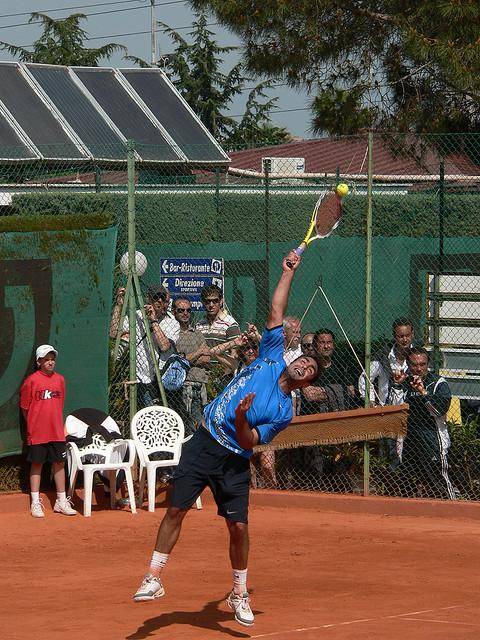What powers the lights here?

Choices:
A) hot water
B) oil
C) gas
D) solar panels solar panels 